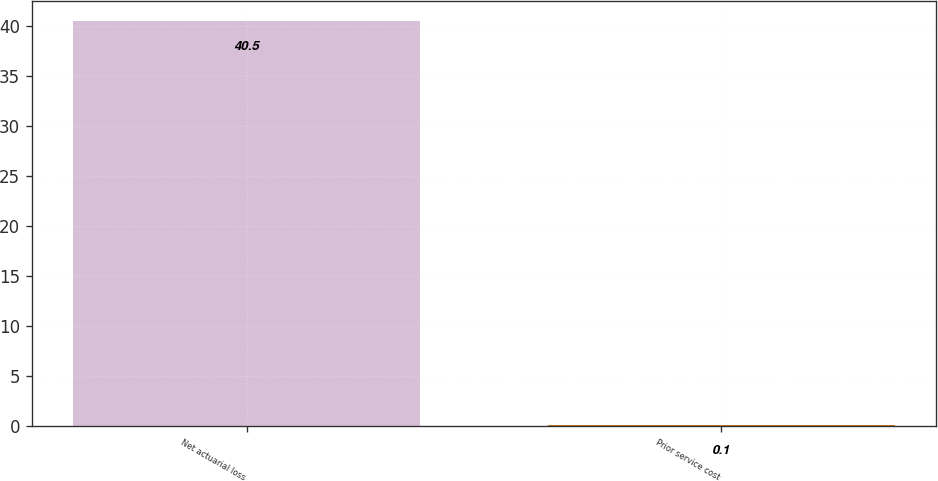Convert chart. <chart><loc_0><loc_0><loc_500><loc_500><bar_chart><fcel>Net actuarial loss<fcel>Prior service cost<nl><fcel>40.5<fcel>0.1<nl></chart> 